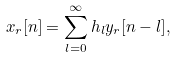<formula> <loc_0><loc_0><loc_500><loc_500>x _ { r } [ n ] = \sum _ { l = 0 } ^ { \infty } h _ { l } y _ { r } [ n - l ] ,</formula> 